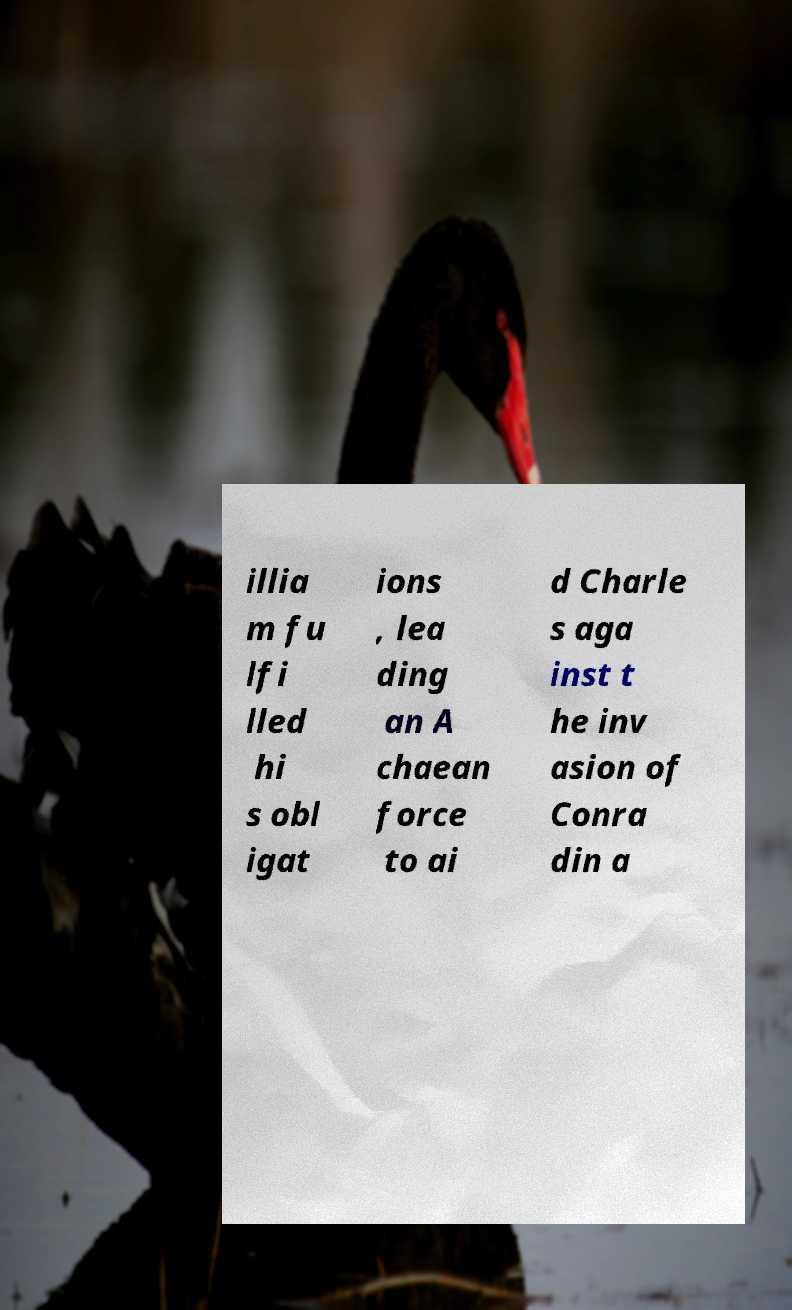Could you assist in decoding the text presented in this image and type it out clearly? illia m fu lfi lled hi s obl igat ions , lea ding an A chaean force to ai d Charle s aga inst t he inv asion of Conra din a 